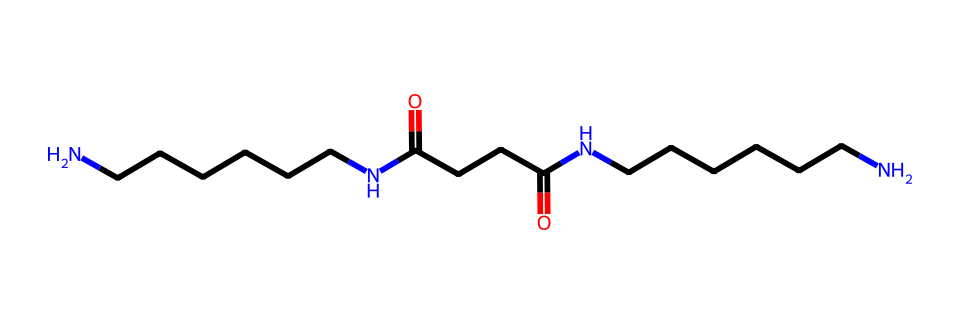What is the name of this chemical structure? The chemical structure corresponds to nylon due to its repeating amide linkages (-C(=O)N-) connected by hydrocarbon chains.
Answer: nylon How many nitrogen atoms are present in the structure? By reviewing the SMILES representation, there are two nitrogen atoms present in the amide groups within the structure.
Answer: two What type of bonding is primarily responsible for the strength of nylon fibers? The strength of nylon fibers is primarily due to hydrogen bonding between the amide groups, which stabilizes the polymer structure.
Answer: hydrogen bonding What functional groups can be identified in this chemical? The primary functional groups present in the structure are amides (due to -C(=O)N) along with hydrocarbon chains.
Answer: amides How many carbon atoms are there in this chemical structure? Analyzing the SMILES, we can count a total of 16 carbon atoms which are part of the repeating units in the nylon structure.
Answer: sixteen What property of nylon fibers makes them suitable for outdoor gear? Nylon fibers are known for their high tensile strength and resistance to abrasion, making them ideal for outdoor applications.
Answer: high tensile strength What type of polymer is represented by this chemical structure? This chemical structure represents a synthetic polymer, specifically a polyamide, notable for its durability and resilience.
Answer: polyamide 